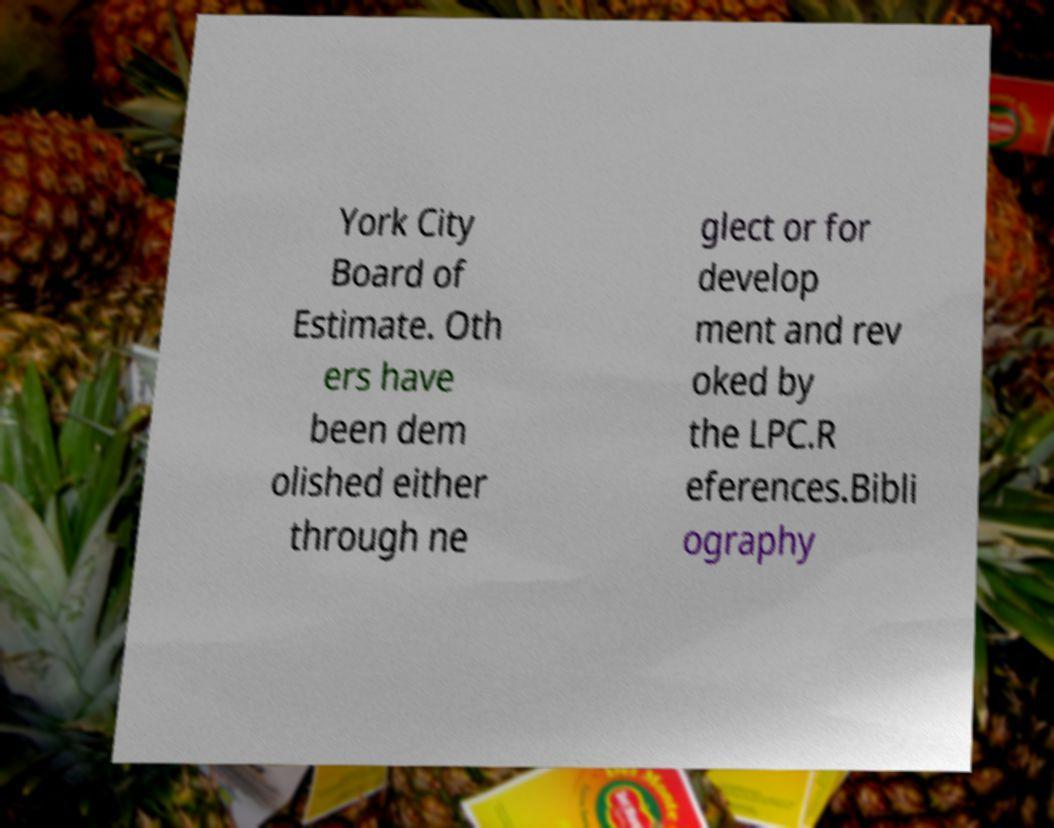Could you extract and type out the text from this image? York City Board of Estimate. Oth ers have been dem olished either through ne glect or for develop ment and rev oked by the LPC.R eferences.Bibli ography 